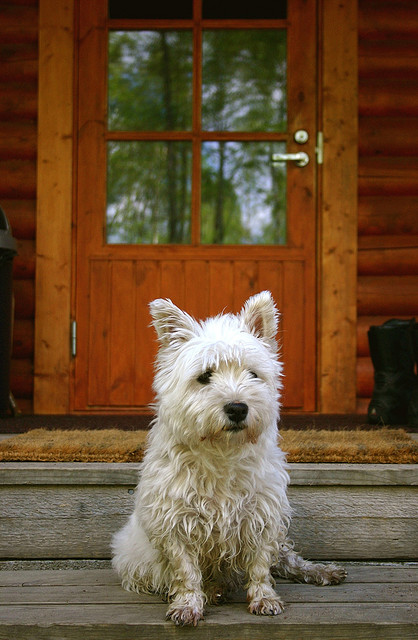What breed of dog is this? The dog in the image appears to be a West Highland White Terrier, commonly known as a Westie. This breed is notable for its distinctive white coat, pointy ears, and bright, button-like eyes. It's a small, sturdy breed with a strong, compact build, perfect for agility and companionship. 